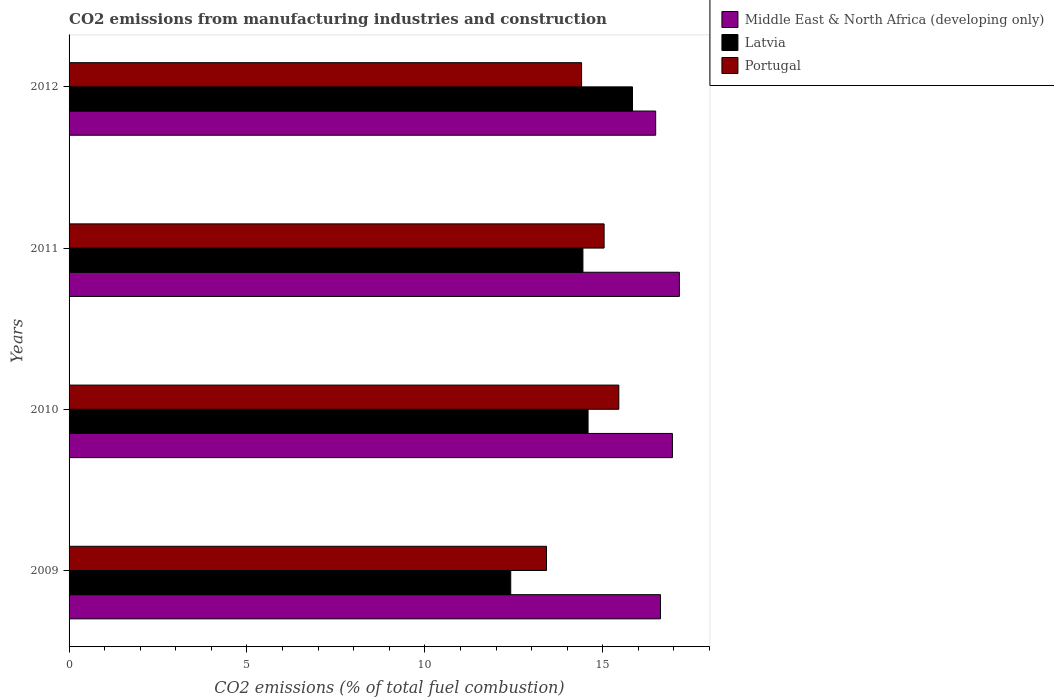Are the number of bars per tick equal to the number of legend labels?
Your response must be concise. Yes. How many bars are there on the 3rd tick from the top?
Give a very brief answer. 3. How many bars are there on the 4th tick from the bottom?
Your answer should be compact. 3. What is the label of the 1st group of bars from the top?
Give a very brief answer. 2012. What is the amount of CO2 emitted in Portugal in 2012?
Give a very brief answer. 14.4. Across all years, what is the maximum amount of CO2 emitted in Portugal?
Your response must be concise. 15.45. Across all years, what is the minimum amount of CO2 emitted in Portugal?
Make the answer very short. 13.42. In which year was the amount of CO2 emitted in Latvia maximum?
Offer a terse response. 2012. In which year was the amount of CO2 emitted in Latvia minimum?
Ensure brevity in your answer.  2009. What is the total amount of CO2 emitted in Middle East & North Africa (developing only) in the graph?
Provide a short and direct response. 67.22. What is the difference between the amount of CO2 emitted in Latvia in 2009 and that in 2011?
Offer a terse response. -2.03. What is the difference between the amount of CO2 emitted in Latvia in 2009 and the amount of CO2 emitted in Portugal in 2011?
Offer a terse response. -2.62. What is the average amount of CO2 emitted in Portugal per year?
Keep it short and to the point. 14.58. In the year 2010, what is the difference between the amount of CO2 emitted in Portugal and amount of CO2 emitted in Latvia?
Make the answer very short. 0.86. In how many years, is the amount of CO2 emitted in Latvia greater than 15 %?
Keep it short and to the point. 1. What is the ratio of the amount of CO2 emitted in Portugal in 2011 to that in 2012?
Provide a short and direct response. 1.04. Is the difference between the amount of CO2 emitted in Portugal in 2009 and 2010 greater than the difference between the amount of CO2 emitted in Latvia in 2009 and 2010?
Provide a succinct answer. Yes. What is the difference between the highest and the second highest amount of CO2 emitted in Portugal?
Offer a terse response. 0.41. What is the difference between the highest and the lowest amount of CO2 emitted in Latvia?
Offer a very short reply. 3.42. What does the 2nd bar from the top in 2010 represents?
Offer a very short reply. Latvia. What does the 1st bar from the bottom in 2010 represents?
Ensure brevity in your answer.  Middle East & North Africa (developing only). How many bars are there?
Your answer should be compact. 12. What is the difference between two consecutive major ticks on the X-axis?
Make the answer very short. 5. Are the values on the major ticks of X-axis written in scientific E-notation?
Offer a terse response. No. Where does the legend appear in the graph?
Offer a terse response. Top right. How many legend labels are there?
Your response must be concise. 3. What is the title of the graph?
Offer a very short reply. CO2 emissions from manufacturing industries and construction. What is the label or title of the X-axis?
Your answer should be very brief. CO2 emissions (% of total fuel combustion). What is the label or title of the Y-axis?
Your answer should be compact. Years. What is the CO2 emissions (% of total fuel combustion) in Middle East & North Africa (developing only) in 2009?
Offer a very short reply. 16.62. What is the CO2 emissions (% of total fuel combustion) of Latvia in 2009?
Your answer should be compact. 12.41. What is the CO2 emissions (% of total fuel combustion) of Portugal in 2009?
Offer a very short reply. 13.42. What is the CO2 emissions (% of total fuel combustion) of Middle East & North Africa (developing only) in 2010?
Offer a very short reply. 16.96. What is the CO2 emissions (% of total fuel combustion) of Latvia in 2010?
Ensure brevity in your answer.  14.59. What is the CO2 emissions (% of total fuel combustion) in Portugal in 2010?
Give a very brief answer. 15.45. What is the CO2 emissions (% of total fuel combustion) in Middle East & North Africa (developing only) in 2011?
Offer a very short reply. 17.15. What is the CO2 emissions (% of total fuel combustion) of Latvia in 2011?
Offer a terse response. 14.44. What is the CO2 emissions (% of total fuel combustion) in Portugal in 2011?
Make the answer very short. 15.04. What is the CO2 emissions (% of total fuel combustion) of Middle East & North Africa (developing only) in 2012?
Offer a very short reply. 16.49. What is the CO2 emissions (% of total fuel combustion) in Latvia in 2012?
Give a very brief answer. 15.83. What is the CO2 emissions (% of total fuel combustion) of Portugal in 2012?
Offer a terse response. 14.4. Across all years, what is the maximum CO2 emissions (% of total fuel combustion) of Middle East & North Africa (developing only)?
Give a very brief answer. 17.15. Across all years, what is the maximum CO2 emissions (% of total fuel combustion) of Latvia?
Ensure brevity in your answer.  15.83. Across all years, what is the maximum CO2 emissions (% of total fuel combustion) in Portugal?
Your answer should be very brief. 15.45. Across all years, what is the minimum CO2 emissions (% of total fuel combustion) in Middle East & North Africa (developing only)?
Provide a succinct answer. 16.49. Across all years, what is the minimum CO2 emissions (% of total fuel combustion) in Latvia?
Give a very brief answer. 12.41. Across all years, what is the minimum CO2 emissions (% of total fuel combustion) of Portugal?
Offer a terse response. 13.42. What is the total CO2 emissions (% of total fuel combustion) of Middle East & North Africa (developing only) in the graph?
Keep it short and to the point. 67.22. What is the total CO2 emissions (% of total fuel combustion) in Latvia in the graph?
Offer a very short reply. 57.27. What is the total CO2 emissions (% of total fuel combustion) of Portugal in the graph?
Your answer should be compact. 58.31. What is the difference between the CO2 emissions (% of total fuel combustion) in Middle East & North Africa (developing only) in 2009 and that in 2010?
Make the answer very short. -0.34. What is the difference between the CO2 emissions (% of total fuel combustion) in Latvia in 2009 and that in 2010?
Offer a very short reply. -2.17. What is the difference between the CO2 emissions (% of total fuel combustion) of Portugal in 2009 and that in 2010?
Give a very brief answer. -2.03. What is the difference between the CO2 emissions (% of total fuel combustion) in Middle East & North Africa (developing only) in 2009 and that in 2011?
Keep it short and to the point. -0.53. What is the difference between the CO2 emissions (% of total fuel combustion) in Latvia in 2009 and that in 2011?
Provide a succinct answer. -2.03. What is the difference between the CO2 emissions (% of total fuel combustion) in Portugal in 2009 and that in 2011?
Keep it short and to the point. -1.62. What is the difference between the CO2 emissions (% of total fuel combustion) of Middle East & North Africa (developing only) in 2009 and that in 2012?
Your answer should be very brief. 0.13. What is the difference between the CO2 emissions (% of total fuel combustion) in Latvia in 2009 and that in 2012?
Make the answer very short. -3.42. What is the difference between the CO2 emissions (% of total fuel combustion) of Portugal in 2009 and that in 2012?
Offer a very short reply. -0.99. What is the difference between the CO2 emissions (% of total fuel combustion) of Middle East & North Africa (developing only) in 2010 and that in 2011?
Offer a terse response. -0.2. What is the difference between the CO2 emissions (% of total fuel combustion) in Latvia in 2010 and that in 2011?
Your answer should be compact. 0.14. What is the difference between the CO2 emissions (% of total fuel combustion) of Portugal in 2010 and that in 2011?
Offer a very short reply. 0.41. What is the difference between the CO2 emissions (% of total fuel combustion) in Middle East & North Africa (developing only) in 2010 and that in 2012?
Make the answer very short. 0.47. What is the difference between the CO2 emissions (% of total fuel combustion) in Latvia in 2010 and that in 2012?
Provide a short and direct response. -1.25. What is the difference between the CO2 emissions (% of total fuel combustion) in Portugal in 2010 and that in 2012?
Ensure brevity in your answer.  1.05. What is the difference between the CO2 emissions (% of total fuel combustion) in Middle East & North Africa (developing only) in 2011 and that in 2012?
Your answer should be very brief. 0.67. What is the difference between the CO2 emissions (% of total fuel combustion) in Latvia in 2011 and that in 2012?
Offer a very short reply. -1.39. What is the difference between the CO2 emissions (% of total fuel combustion) in Portugal in 2011 and that in 2012?
Provide a short and direct response. 0.63. What is the difference between the CO2 emissions (% of total fuel combustion) of Middle East & North Africa (developing only) in 2009 and the CO2 emissions (% of total fuel combustion) of Latvia in 2010?
Your answer should be compact. 2.03. What is the difference between the CO2 emissions (% of total fuel combustion) of Middle East & North Africa (developing only) in 2009 and the CO2 emissions (% of total fuel combustion) of Portugal in 2010?
Your answer should be compact. 1.17. What is the difference between the CO2 emissions (% of total fuel combustion) of Latvia in 2009 and the CO2 emissions (% of total fuel combustion) of Portugal in 2010?
Keep it short and to the point. -3.04. What is the difference between the CO2 emissions (% of total fuel combustion) in Middle East & North Africa (developing only) in 2009 and the CO2 emissions (% of total fuel combustion) in Latvia in 2011?
Ensure brevity in your answer.  2.18. What is the difference between the CO2 emissions (% of total fuel combustion) of Middle East & North Africa (developing only) in 2009 and the CO2 emissions (% of total fuel combustion) of Portugal in 2011?
Offer a terse response. 1.58. What is the difference between the CO2 emissions (% of total fuel combustion) of Latvia in 2009 and the CO2 emissions (% of total fuel combustion) of Portugal in 2011?
Give a very brief answer. -2.62. What is the difference between the CO2 emissions (% of total fuel combustion) in Middle East & North Africa (developing only) in 2009 and the CO2 emissions (% of total fuel combustion) in Latvia in 2012?
Provide a succinct answer. 0.79. What is the difference between the CO2 emissions (% of total fuel combustion) in Middle East & North Africa (developing only) in 2009 and the CO2 emissions (% of total fuel combustion) in Portugal in 2012?
Your answer should be very brief. 2.22. What is the difference between the CO2 emissions (% of total fuel combustion) of Latvia in 2009 and the CO2 emissions (% of total fuel combustion) of Portugal in 2012?
Provide a short and direct response. -1.99. What is the difference between the CO2 emissions (% of total fuel combustion) of Middle East & North Africa (developing only) in 2010 and the CO2 emissions (% of total fuel combustion) of Latvia in 2011?
Offer a very short reply. 2.52. What is the difference between the CO2 emissions (% of total fuel combustion) of Middle East & North Africa (developing only) in 2010 and the CO2 emissions (% of total fuel combustion) of Portugal in 2011?
Offer a very short reply. 1.92. What is the difference between the CO2 emissions (% of total fuel combustion) of Latvia in 2010 and the CO2 emissions (% of total fuel combustion) of Portugal in 2011?
Make the answer very short. -0.45. What is the difference between the CO2 emissions (% of total fuel combustion) of Middle East & North Africa (developing only) in 2010 and the CO2 emissions (% of total fuel combustion) of Latvia in 2012?
Your response must be concise. 1.12. What is the difference between the CO2 emissions (% of total fuel combustion) in Middle East & North Africa (developing only) in 2010 and the CO2 emissions (% of total fuel combustion) in Portugal in 2012?
Ensure brevity in your answer.  2.55. What is the difference between the CO2 emissions (% of total fuel combustion) of Latvia in 2010 and the CO2 emissions (% of total fuel combustion) of Portugal in 2012?
Keep it short and to the point. 0.18. What is the difference between the CO2 emissions (% of total fuel combustion) in Middle East & North Africa (developing only) in 2011 and the CO2 emissions (% of total fuel combustion) in Latvia in 2012?
Your response must be concise. 1.32. What is the difference between the CO2 emissions (% of total fuel combustion) of Middle East & North Africa (developing only) in 2011 and the CO2 emissions (% of total fuel combustion) of Portugal in 2012?
Your answer should be compact. 2.75. What is the difference between the CO2 emissions (% of total fuel combustion) in Latvia in 2011 and the CO2 emissions (% of total fuel combustion) in Portugal in 2012?
Give a very brief answer. 0.04. What is the average CO2 emissions (% of total fuel combustion) in Middle East & North Africa (developing only) per year?
Provide a succinct answer. 16.8. What is the average CO2 emissions (% of total fuel combustion) of Latvia per year?
Make the answer very short. 14.32. What is the average CO2 emissions (% of total fuel combustion) in Portugal per year?
Your answer should be compact. 14.58. In the year 2009, what is the difference between the CO2 emissions (% of total fuel combustion) in Middle East & North Africa (developing only) and CO2 emissions (% of total fuel combustion) in Latvia?
Your response must be concise. 4.21. In the year 2009, what is the difference between the CO2 emissions (% of total fuel combustion) in Middle East & North Africa (developing only) and CO2 emissions (% of total fuel combustion) in Portugal?
Keep it short and to the point. 3.2. In the year 2009, what is the difference between the CO2 emissions (% of total fuel combustion) of Latvia and CO2 emissions (% of total fuel combustion) of Portugal?
Ensure brevity in your answer.  -1.01. In the year 2010, what is the difference between the CO2 emissions (% of total fuel combustion) of Middle East & North Africa (developing only) and CO2 emissions (% of total fuel combustion) of Latvia?
Ensure brevity in your answer.  2.37. In the year 2010, what is the difference between the CO2 emissions (% of total fuel combustion) of Middle East & North Africa (developing only) and CO2 emissions (% of total fuel combustion) of Portugal?
Your response must be concise. 1.51. In the year 2010, what is the difference between the CO2 emissions (% of total fuel combustion) of Latvia and CO2 emissions (% of total fuel combustion) of Portugal?
Keep it short and to the point. -0.86. In the year 2011, what is the difference between the CO2 emissions (% of total fuel combustion) in Middle East & North Africa (developing only) and CO2 emissions (% of total fuel combustion) in Latvia?
Offer a terse response. 2.71. In the year 2011, what is the difference between the CO2 emissions (% of total fuel combustion) of Middle East & North Africa (developing only) and CO2 emissions (% of total fuel combustion) of Portugal?
Keep it short and to the point. 2.12. In the year 2011, what is the difference between the CO2 emissions (% of total fuel combustion) of Latvia and CO2 emissions (% of total fuel combustion) of Portugal?
Your response must be concise. -0.6. In the year 2012, what is the difference between the CO2 emissions (% of total fuel combustion) in Middle East & North Africa (developing only) and CO2 emissions (% of total fuel combustion) in Latvia?
Make the answer very short. 0.65. In the year 2012, what is the difference between the CO2 emissions (% of total fuel combustion) of Middle East & North Africa (developing only) and CO2 emissions (% of total fuel combustion) of Portugal?
Your response must be concise. 2.08. In the year 2012, what is the difference between the CO2 emissions (% of total fuel combustion) of Latvia and CO2 emissions (% of total fuel combustion) of Portugal?
Provide a succinct answer. 1.43. What is the ratio of the CO2 emissions (% of total fuel combustion) in Middle East & North Africa (developing only) in 2009 to that in 2010?
Your answer should be compact. 0.98. What is the ratio of the CO2 emissions (% of total fuel combustion) in Latvia in 2009 to that in 2010?
Provide a short and direct response. 0.85. What is the ratio of the CO2 emissions (% of total fuel combustion) in Portugal in 2009 to that in 2010?
Your answer should be compact. 0.87. What is the ratio of the CO2 emissions (% of total fuel combustion) in Middle East & North Africa (developing only) in 2009 to that in 2011?
Give a very brief answer. 0.97. What is the ratio of the CO2 emissions (% of total fuel combustion) of Latvia in 2009 to that in 2011?
Keep it short and to the point. 0.86. What is the ratio of the CO2 emissions (% of total fuel combustion) of Portugal in 2009 to that in 2011?
Ensure brevity in your answer.  0.89. What is the ratio of the CO2 emissions (% of total fuel combustion) in Middle East & North Africa (developing only) in 2009 to that in 2012?
Keep it short and to the point. 1.01. What is the ratio of the CO2 emissions (% of total fuel combustion) in Latvia in 2009 to that in 2012?
Make the answer very short. 0.78. What is the ratio of the CO2 emissions (% of total fuel combustion) in Portugal in 2009 to that in 2012?
Offer a very short reply. 0.93. What is the ratio of the CO2 emissions (% of total fuel combustion) of Middle East & North Africa (developing only) in 2010 to that in 2011?
Your answer should be compact. 0.99. What is the ratio of the CO2 emissions (% of total fuel combustion) of Portugal in 2010 to that in 2011?
Offer a very short reply. 1.03. What is the ratio of the CO2 emissions (% of total fuel combustion) in Middle East & North Africa (developing only) in 2010 to that in 2012?
Your response must be concise. 1.03. What is the ratio of the CO2 emissions (% of total fuel combustion) in Latvia in 2010 to that in 2012?
Ensure brevity in your answer.  0.92. What is the ratio of the CO2 emissions (% of total fuel combustion) in Portugal in 2010 to that in 2012?
Keep it short and to the point. 1.07. What is the ratio of the CO2 emissions (% of total fuel combustion) in Middle East & North Africa (developing only) in 2011 to that in 2012?
Your response must be concise. 1.04. What is the ratio of the CO2 emissions (% of total fuel combustion) in Latvia in 2011 to that in 2012?
Give a very brief answer. 0.91. What is the ratio of the CO2 emissions (% of total fuel combustion) in Portugal in 2011 to that in 2012?
Provide a short and direct response. 1.04. What is the difference between the highest and the second highest CO2 emissions (% of total fuel combustion) of Middle East & North Africa (developing only)?
Your response must be concise. 0.2. What is the difference between the highest and the second highest CO2 emissions (% of total fuel combustion) of Latvia?
Make the answer very short. 1.25. What is the difference between the highest and the second highest CO2 emissions (% of total fuel combustion) in Portugal?
Offer a very short reply. 0.41. What is the difference between the highest and the lowest CO2 emissions (% of total fuel combustion) in Middle East & North Africa (developing only)?
Offer a very short reply. 0.67. What is the difference between the highest and the lowest CO2 emissions (% of total fuel combustion) of Latvia?
Keep it short and to the point. 3.42. What is the difference between the highest and the lowest CO2 emissions (% of total fuel combustion) in Portugal?
Make the answer very short. 2.03. 